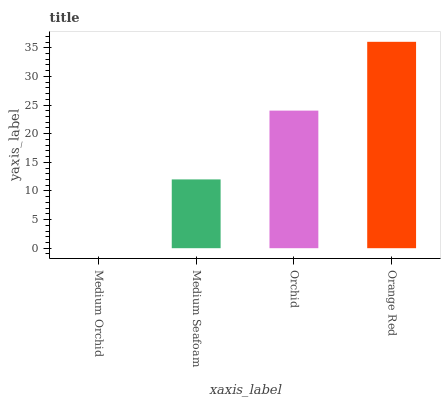Is Medium Seafoam the minimum?
Answer yes or no. No. Is Medium Seafoam the maximum?
Answer yes or no. No. Is Medium Seafoam greater than Medium Orchid?
Answer yes or no. Yes. Is Medium Orchid less than Medium Seafoam?
Answer yes or no. Yes. Is Medium Orchid greater than Medium Seafoam?
Answer yes or no. No. Is Medium Seafoam less than Medium Orchid?
Answer yes or no. No. Is Orchid the high median?
Answer yes or no. Yes. Is Medium Seafoam the low median?
Answer yes or no. Yes. Is Medium Orchid the high median?
Answer yes or no. No. Is Orange Red the low median?
Answer yes or no. No. 